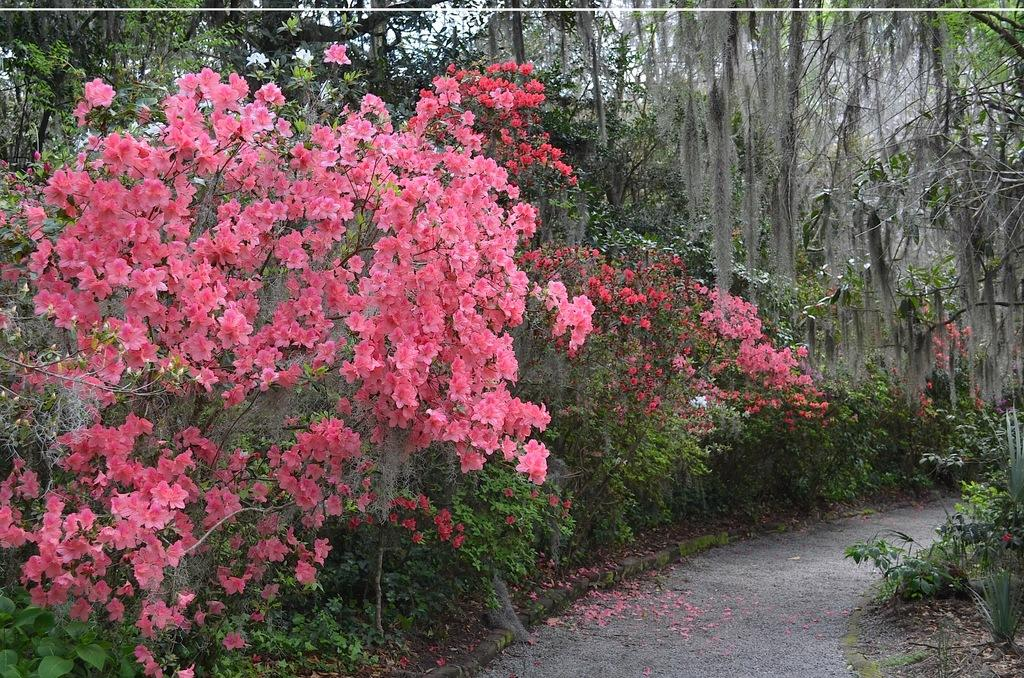What type of vegetation can be seen in the image? There are flowers, plants, and trees in the image. What is located at the bottom of the image? There is a walkway at the bottom of the image. What type of bat is flying near the trees in the image? There are no bats present in the image; it only features flowers, plants, trees, and a walkway. 